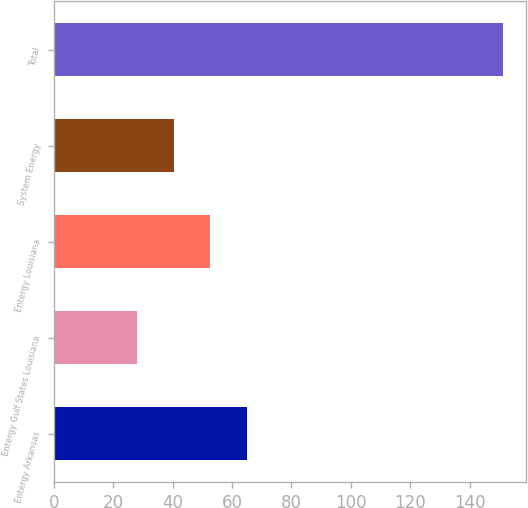Convert chart. <chart><loc_0><loc_0><loc_500><loc_500><bar_chart><fcel>Entergy Arkansas<fcel>Entergy Gulf States Louisiana<fcel>Entergy Louisiana<fcel>System Energy<fcel>Total<nl><fcel>65.09<fcel>28.1<fcel>52.76<fcel>40.43<fcel>151.4<nl></chart> 